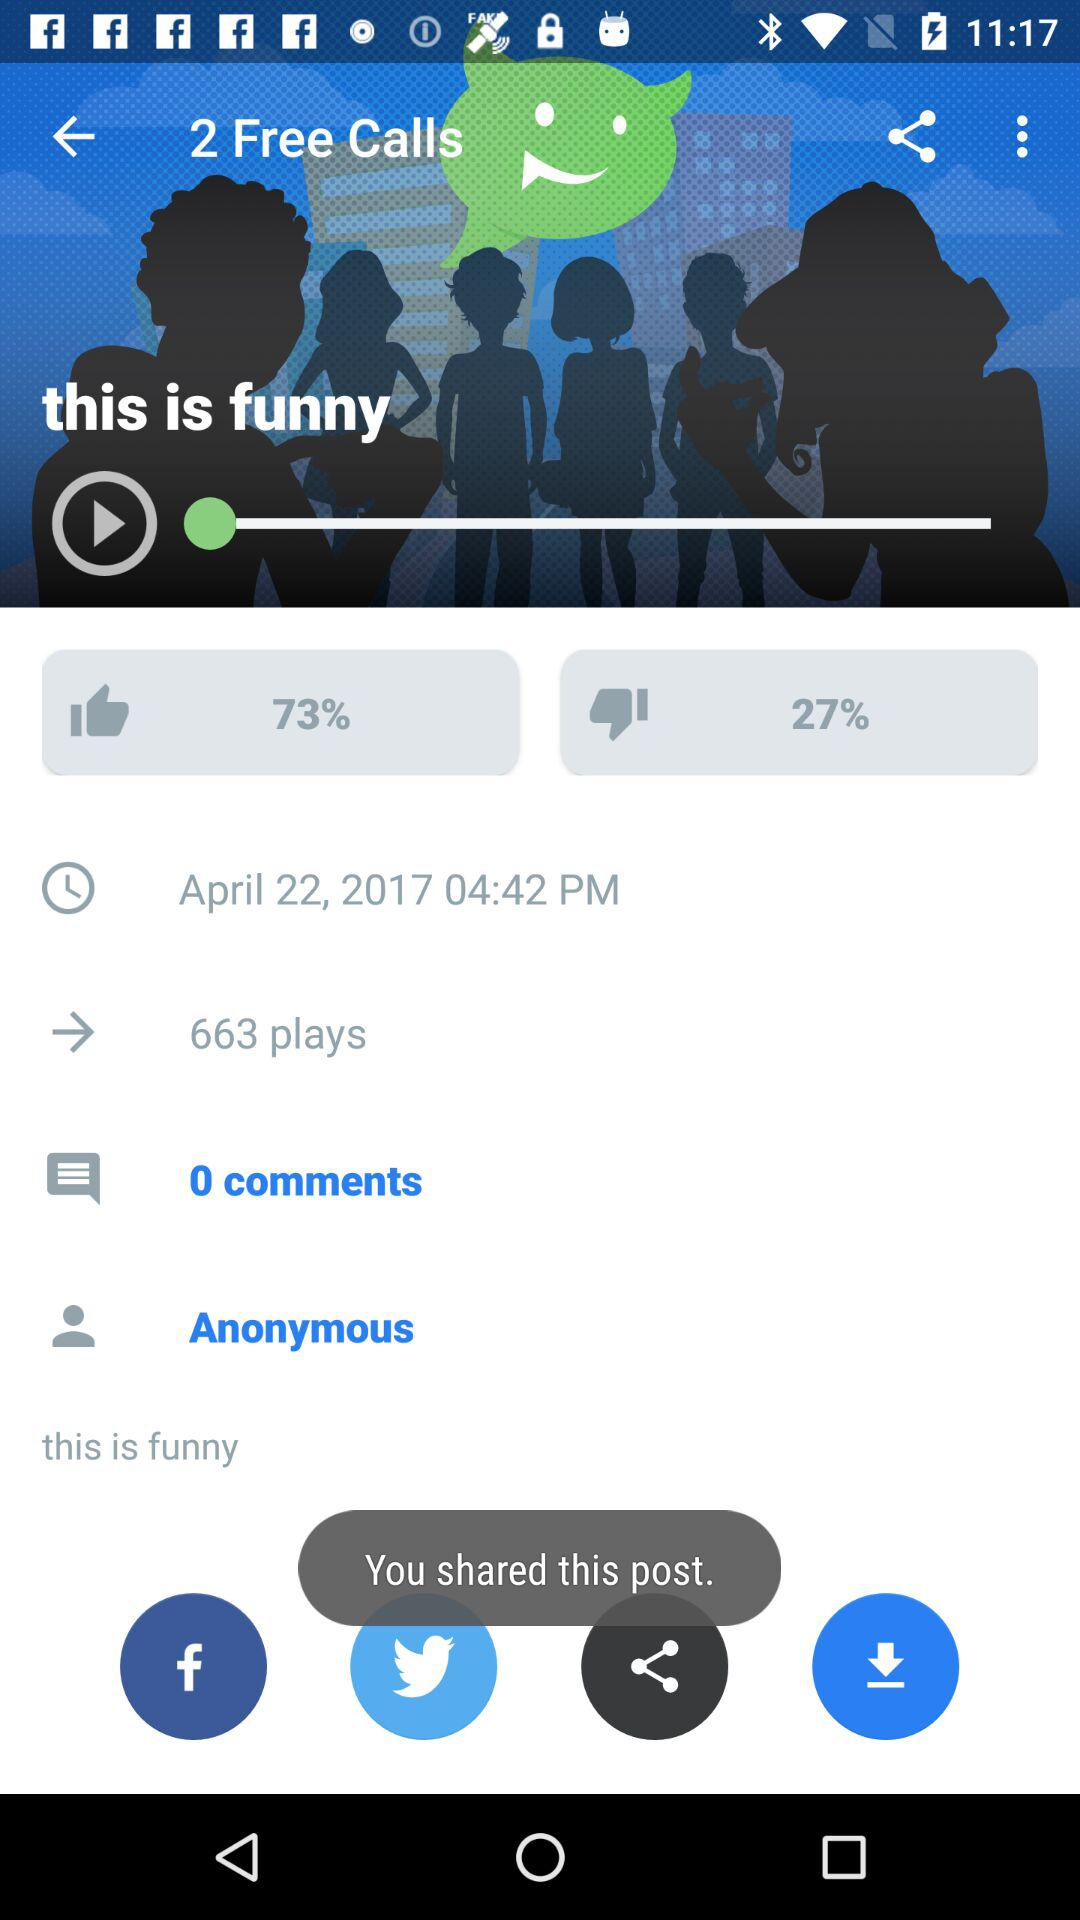What is the dislike percentage? The dislike percentage is 27. 